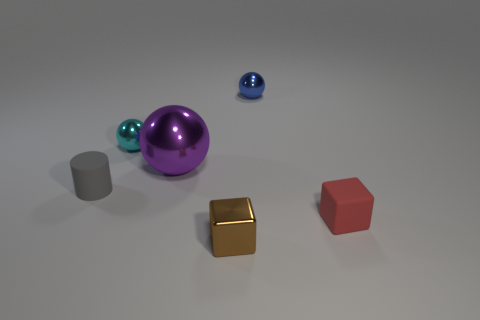Do the sphere in front of the cyan shiny sphere and the tiny gray object have the same material?
Give a very brief answer. No. Do the tiny matte block and the thing that is in front of the red block have the same color?
Your answer should be compact. No. Are there any small cyan shiny spheres in front of the blue shiny ball?
Offer a very short reply. Yes. Do the rubber object on the right side of the small brown shiny cube and the metallic ball right of the tiny brown thing have the same size?
Your response must be concise. Yes. Are there any metallic spheres that have the same size as the rubber cylinder?
Give a very brief answer. Yes. There is a thing that is in front of the small red cube; is its shape the same as the small red thing?
Keep it short and to the point. Yes. There is a small object that is in front of the small red block; what is it made of?
Offer a very short reply. Metal. There is a rubber thing on the left side of the shiny thing on the left side of the purple sphere; what is its shape?
Give a very brief answer. Cylinder. Is the shape of the tiny gray matte thing the same as the rubber thing that is to the right of the small blue object?
Make the answer very short. No. What number of red rubber blocks are behind the blue metallic thing behind the gray matte thing?
Your answer should be compact. 0. 